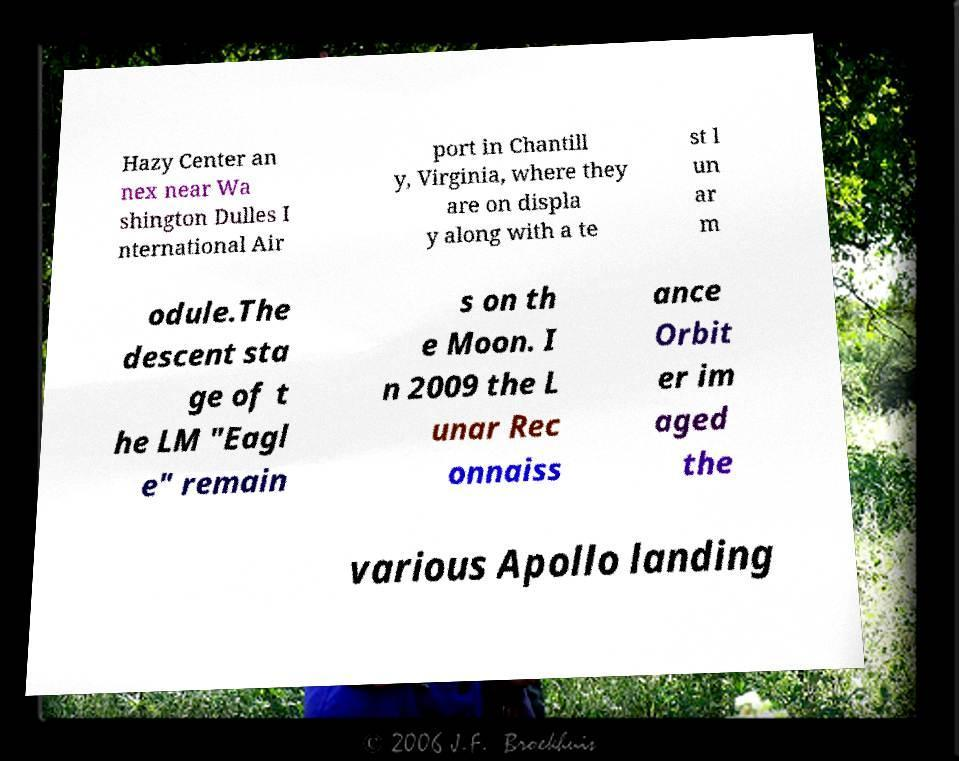There's text embedded in this image that I need extracted. Can you transcribe it verbatim? Hazy Center an nex near Wa shington Dulles I nternational Air port in Chantill y, Virginia, where they are on displa y along with a te st l un ar m odule.The descent sta ge of t he LM "Eagl e" remain s on th e Moon. I n 2009 the L unar Rec onnaiss ance Orbit er im aged the various Apollo landing 